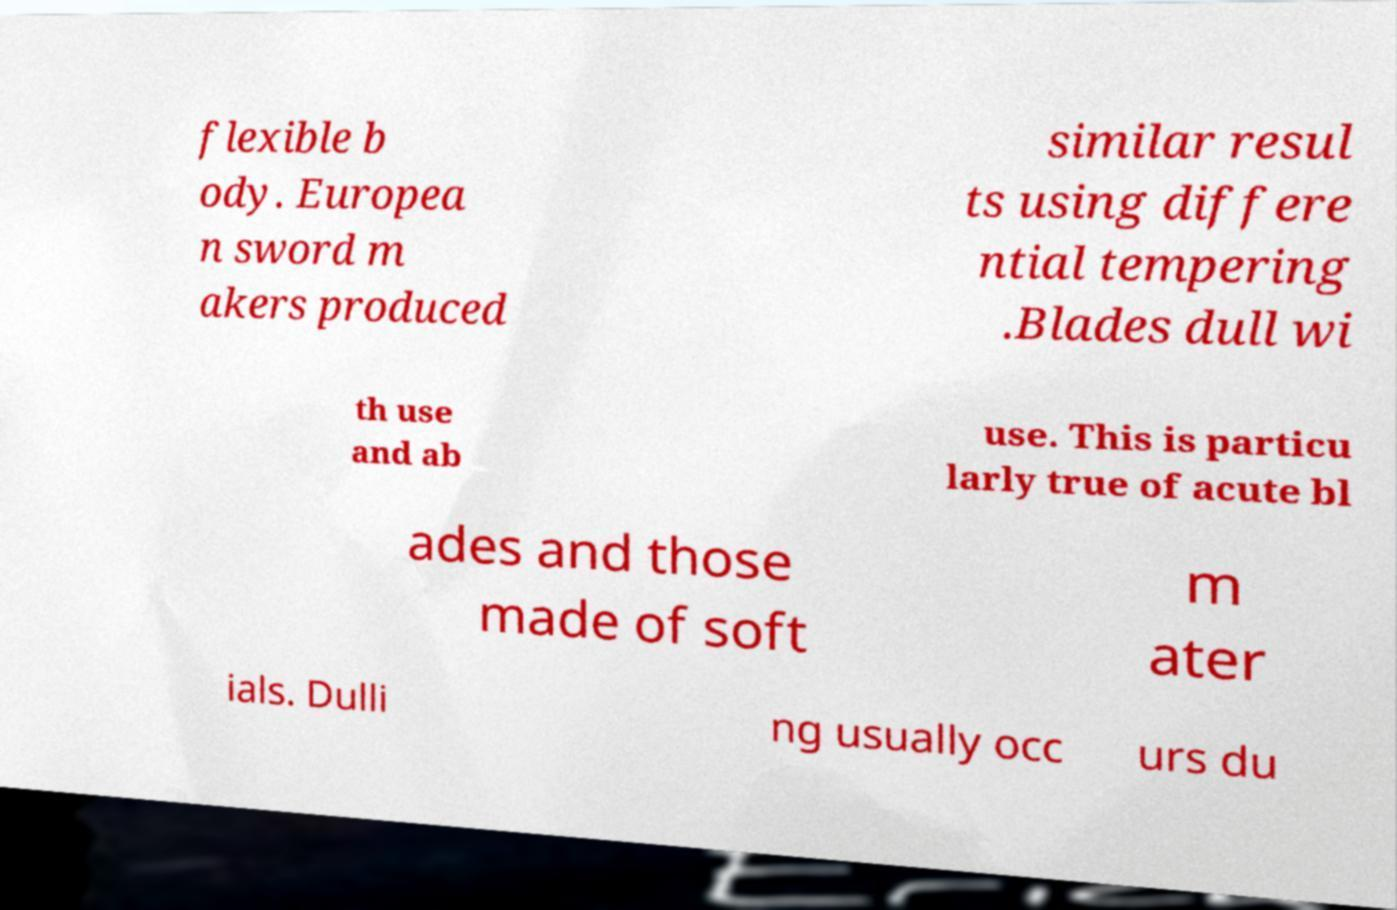Can you read and provide the text displayed in the image?This photo seems to have some interesting text. Can you extract and type it out for me? flexible b ody. Europea n sword m akers produced similar resul ts using differe ntial tempering .Blades dull wi th use and ab use. This is particu larly true of acute bl ades and those made of soft m ater ials. Dulli ng usually occ urs du 